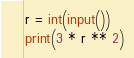<code> <loc_0><loc_0><loc_500><loc_500><_Python_>r = int(input())
print(3 * r ** 2)</code> 